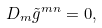Convert formula to latex. <formula><loc_0><loc_0><loc_500><loc_500>D _ { m } \tilde { g } ^ { m n } = 0 ,</formula> 